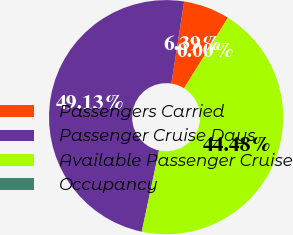Convert chart to OTSL. <chart><loc_0><loc_0><loc_500><loc_500><pie_chart><fcel>Passengers Carried<fcel>Passenger Cruise Days<fcel>Available Passenger Cruise<fcel>Occupancy<nl><fcel>6.39%<fcel>49.13%<fcel>44.48%<fcel>0.0%<nl></chart> 